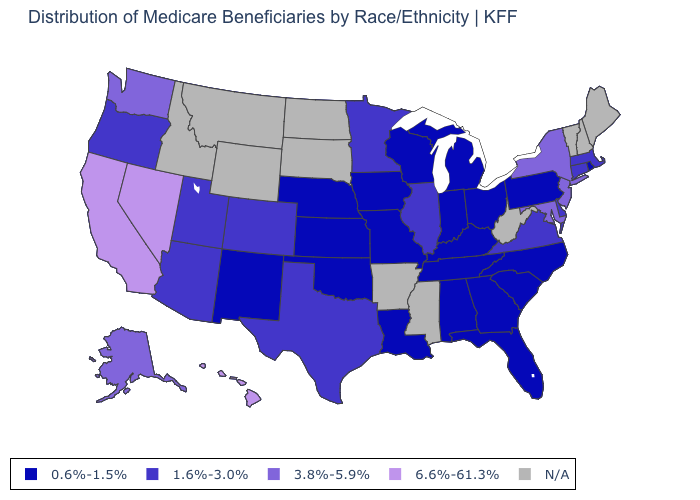Name the states that have a value in the range 6.6%-61.3%?
Keep it brief. California, Hawaii, Nevada. What is the value of Maryland?
Give a very brief answer. 3.8%-5.9%. What is the value of Montana?
Quick response, please. N/A. What is the value of Louisiana?
Be succinct. 0.6%-1.5%. Which states hav the highest value in the Northeast?
Answer briefly. New Jersey, New York. Which states hav the highest value in the West?
Keep it brief. California, Hawaii, Nevada. What is the value of Colorado?
Write a very short answer. 1.6%-3.0%. Among the states that border Nevada , does California have the lowest value?
Answer briefly. No. What is the lowest value in the West?
Quick response, please. 0.6%-1.5%. What is the highest value in the Northeast ?
Keep it brief. 3.8%-5.9%. What is the lowest value in the USA?
Write a very short answer. 0.6%-1.5%. What is the lowest value in states that border Illinois?
Write a very short answer. 0.6%-1.5%. Does New Jersey have the lowest value in the USA?
Quick response, please. No. What is the value of Maryland?
Write a very short answer. 3.8%-5.9%. 